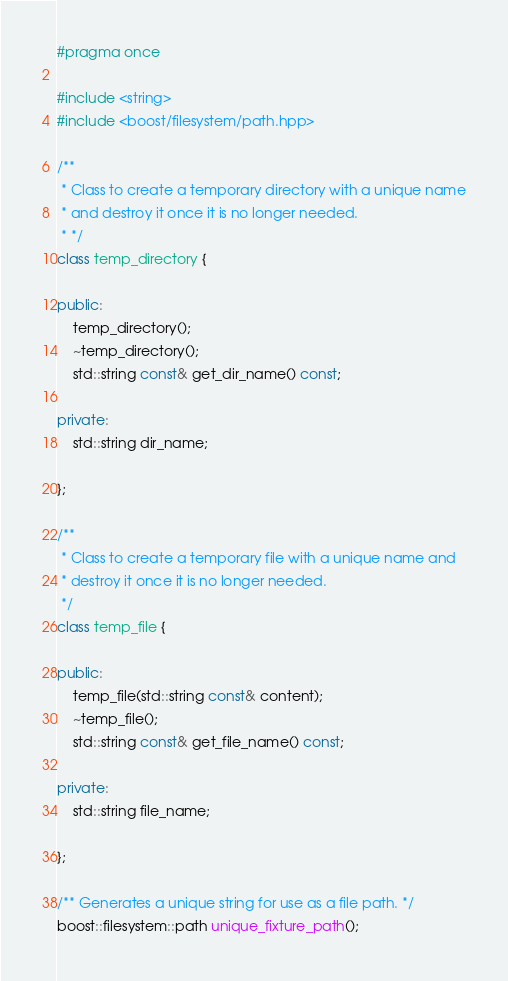Convert code to text. <code><loc_0><loc_0><loc_500><loc_500><_C++_>#pragma once

#include <string>
#include <boost/filesystem/path.hpp>

/**
 * Class to create a temporary directory with a unique name
 * and destroy it once it is no longer needed.
 * */
class temp_directory {

public:
    temp_directory();
    ~temp_directory();
    std::string const& get_dir_name() const;

private:
    std::string dir_name;

};

/**
 * Class to create a temporary file with a unique name and
 * destroy it once it is no longer needed.
 */
class temp_file {

public:
    temp_file(std::string const& content);
    ~temp_file();
    std::string const& get_file_name() const;

private:
    std::string file_name;

};

/** Generates a unique string for use as a file path. */
boost::filesystem::path unique_fixture_path();</code> 